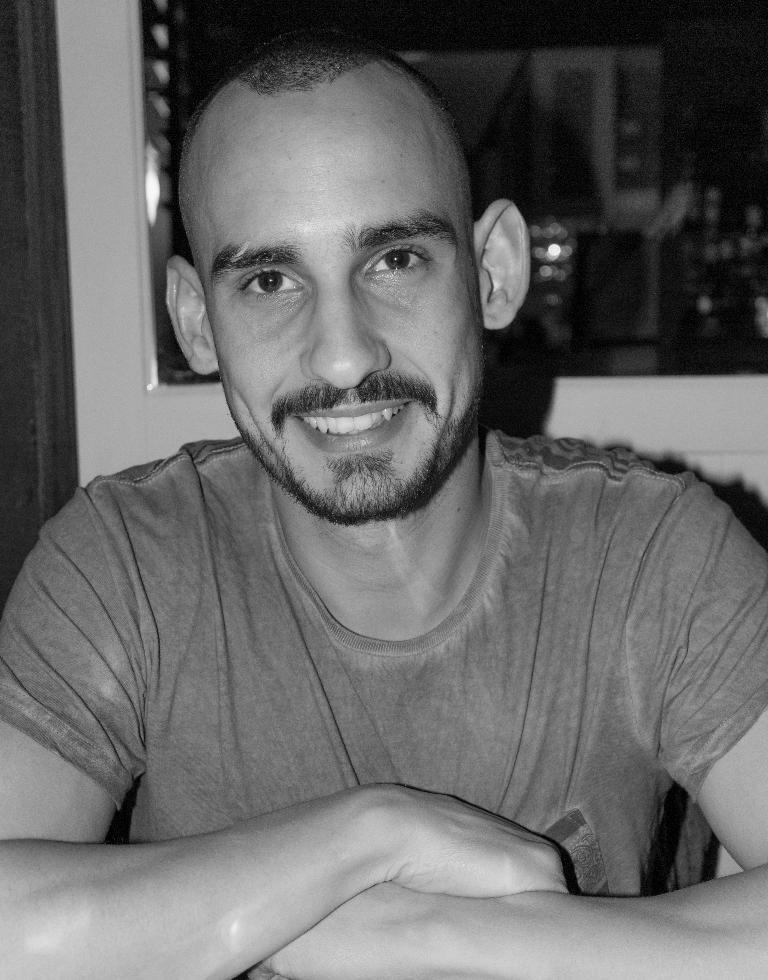What is present in the image? There is a person in the image. How is the person's expression in the image? The person is smiling. What type of stream can be seen flowing through the room in the image? There is no stream or room present in the image; it only features a person who is smiling. 